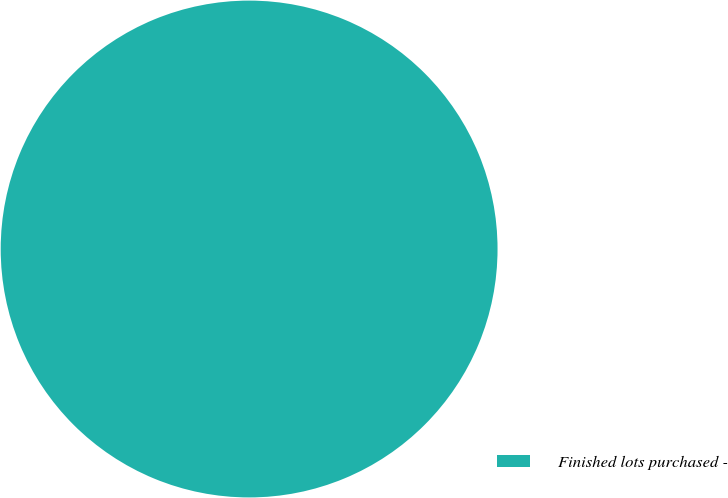Convert chart to OTSL. <chart><loc_0><loc_0><loc_500><loc_500><pie_chart><fcel>Finished lots purchased -<nl><fcel>100.0%<nl></chart> 